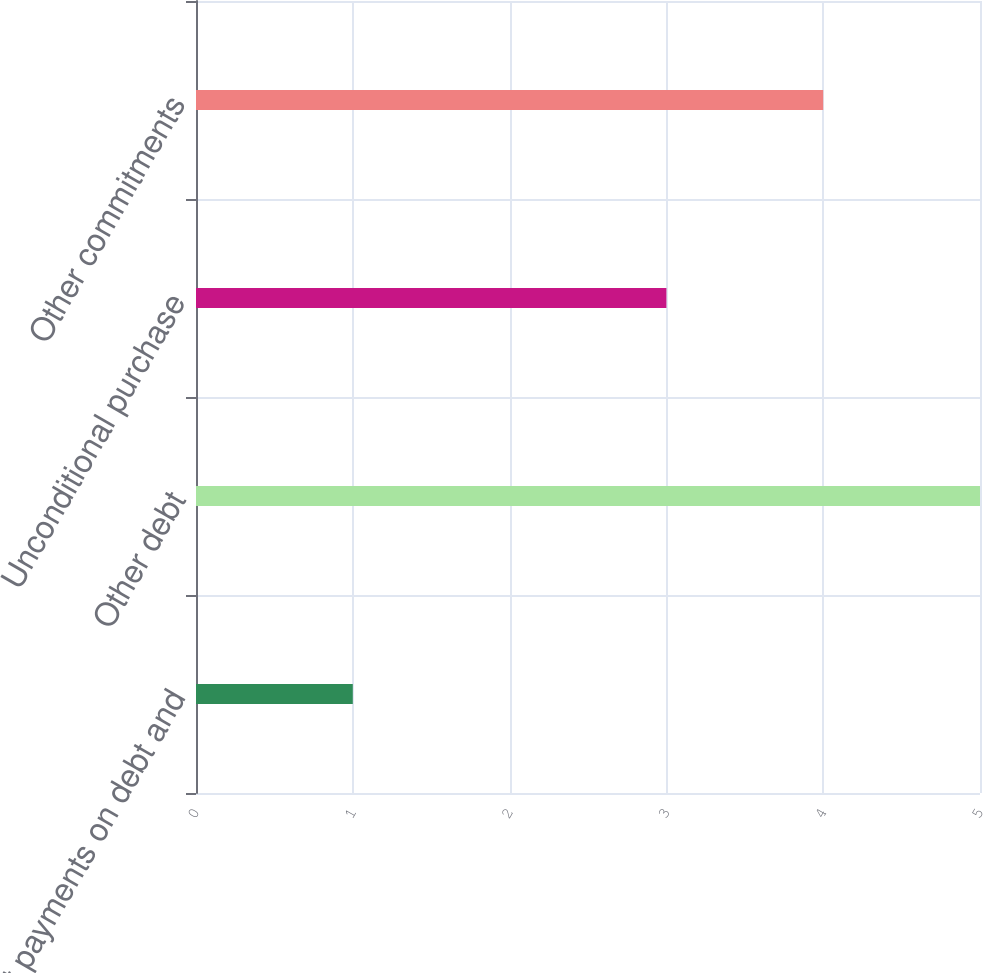Convert chart to OTSL. <chart><loc_0><loc_0><loc_500><loc_500><bar_chart><fcel>Interest payments on debt and<fcel>Other debt<fcel>Unconditional purchase<fcel>Other commitments<nl><fcel>1<fcel>5<fcel>3<fcel>4<nl></chart> 